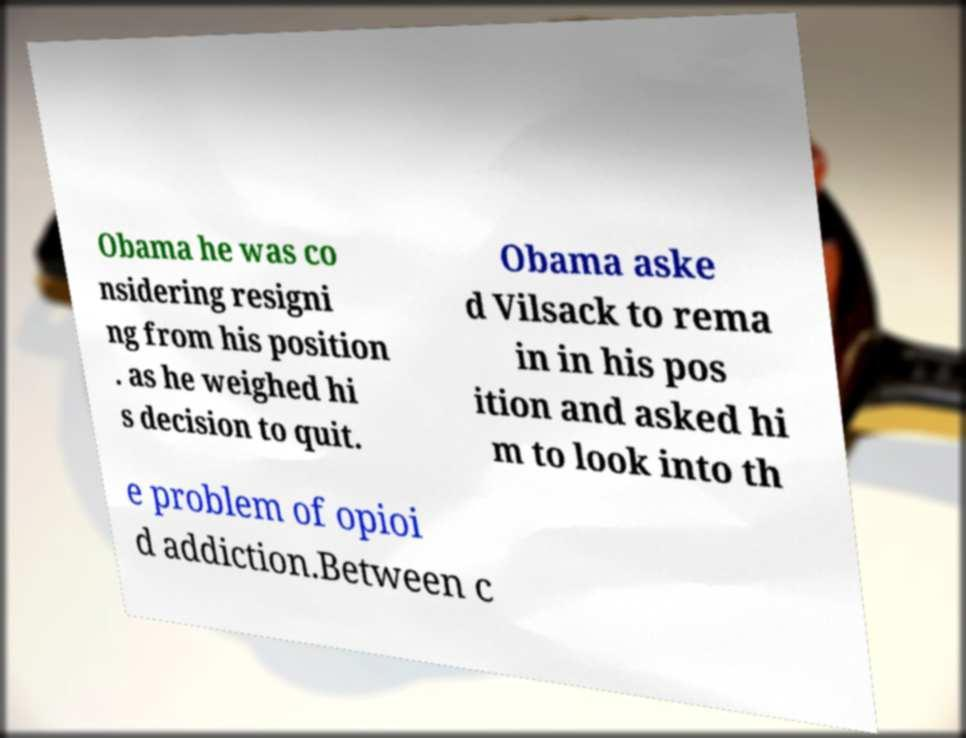What messages or text are displayed in this image? I need them in a readable, typed format. Obama he was co nsidering resigni ng from his position . as he weighed hi s decision to quit. Obama aske d Vilsack to rema in in his pos ition and asked hi m to look into th e problem of opioi d addiction.Between c 